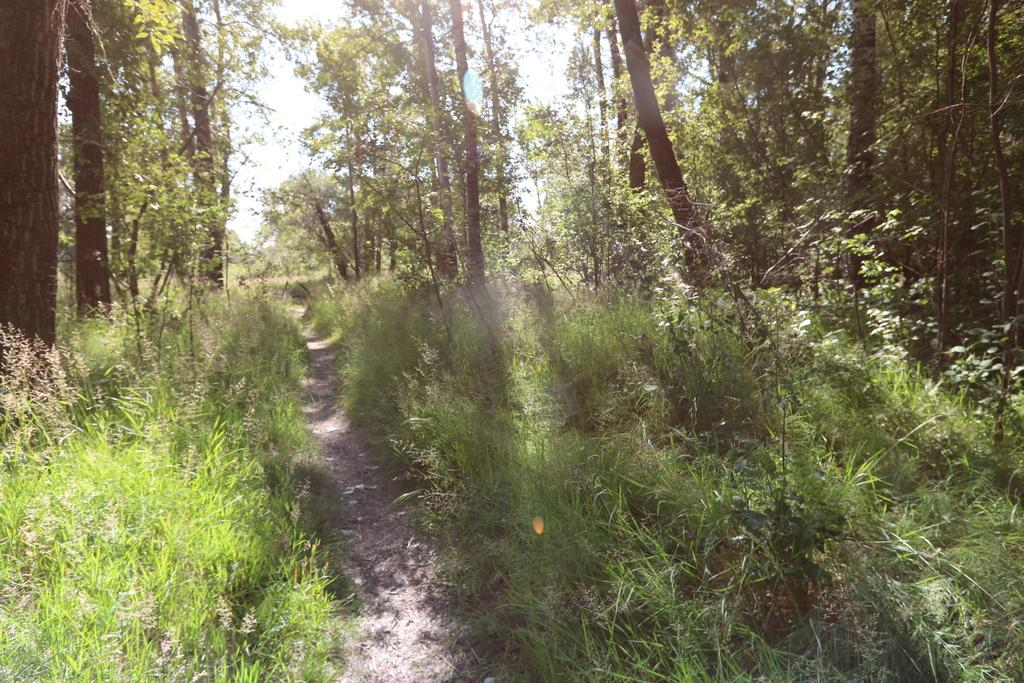What is the main feature in the middle of the image? There is a path in the middle of the image. What can be seen on either side of the path? Plants and trees are present on either side of the path. What is visible above the path? The sky is visible above the path. Where is the table located in the image? There is no table present in the image. What type of drug can be seen in the image? There is no drug present in the image. 